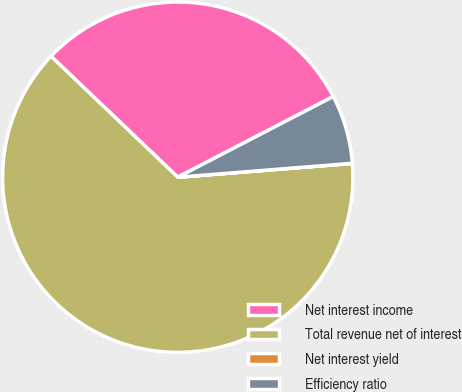<chart> <loc_0><loc_0><loc_500><loc_500><pie_chart><fcel>Net interest income<fcel>Total revenue net of interest<fcel>Net interest yield<fcel>Efficiency ratio<nl><fcel>30.26%<fcel>63.39%<fcel>0.01%<fcel>6.35%<nl></chart> 